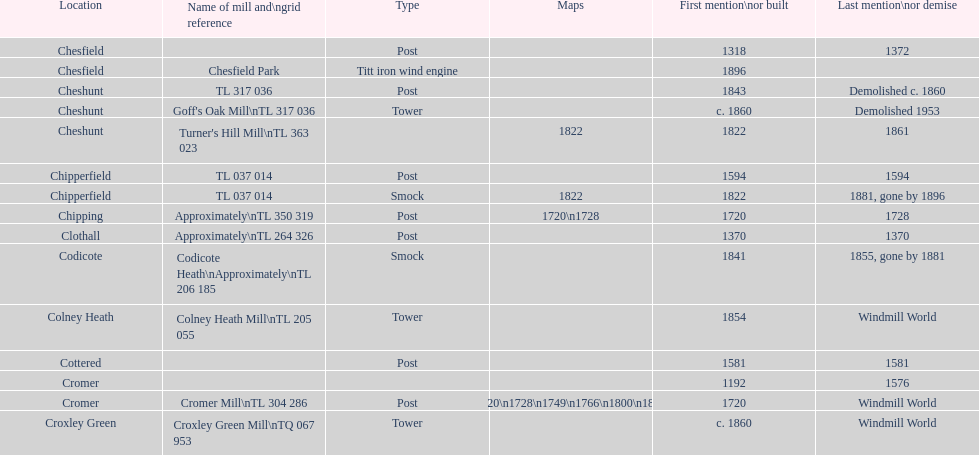After 1800, how many mills were constructed or initially mentioned? 8. 